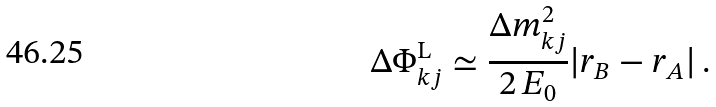<formula> <loc_0><loc_0><loc_500><loc_500>\Delta \Phi _ { k j } ^ { \mathrm L } \simeq \frac { \Delta m _ { k j } ^ { 2 } } { 2 \, E _ { 0 } } | r _ { B } - r _ { A } | \, .</formula> 